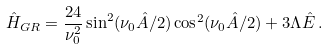Convert formula to latex. <formula><loc_0><loc_0><loc_500><loc_500>\hat { H } _ { G R } = \frac { 2 4 } { \nu _ { 0 } ^ { 2 } } \sin ^ { 2 } ( \nu _ { 0 } \hat { A } / 2 ) \cos ^ { 2 } ( \nu _ { 0 } \hat { A } / 2 ) + 3 \Lambda \hat { E } \, .</formula> 